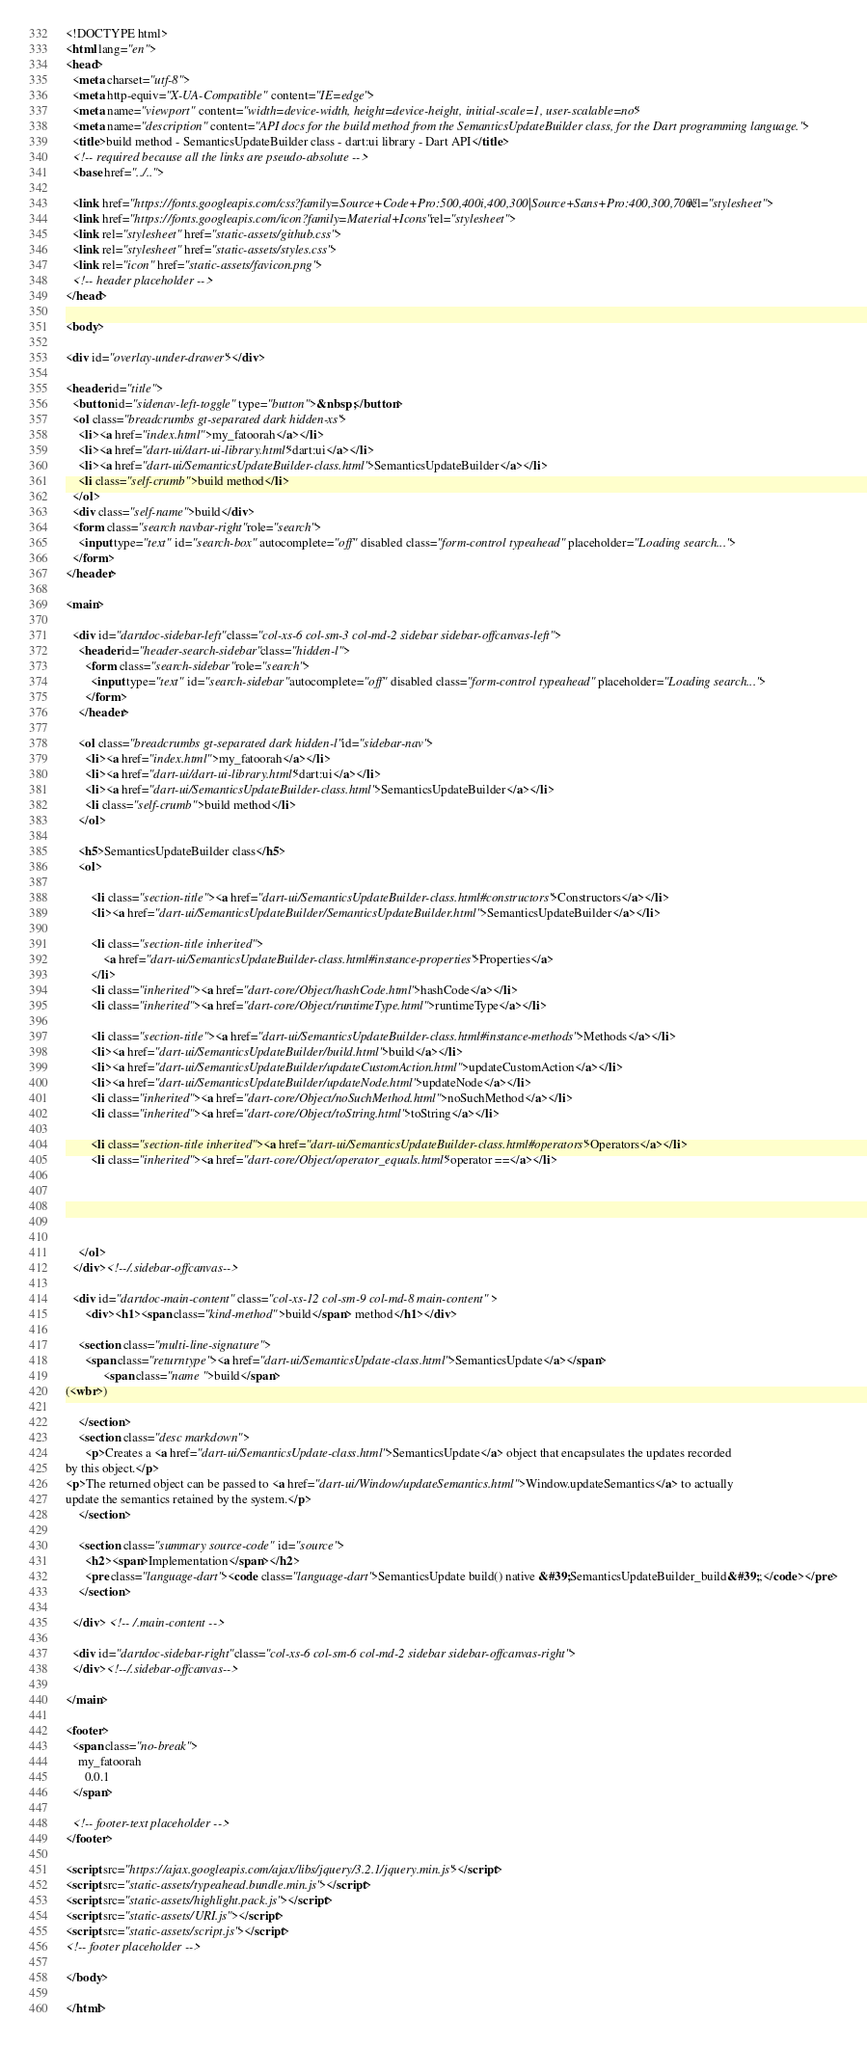<code> <loc_0><loc_0><loc_500><loc_500><_HTML_><!DOCTYPE html>
<html lang="en">
<head>
  <meta charset="utf-8">
  <meta http-equiv="X-UA-Compatible" content="IE=edge">
  <meta name="viewport" content="width=device-width, height=device-height, initial-scale=1, user-scalable=no">
  <meta name="description" content="API docs for the build method from the SemanticsUpdateBuilder class, for the Dart programming language.">
  <title>build method - SemanticsUpdateBuilder class - dart:ui library - Dart API</title>
  <!-- required because all the links are pseudo-absolute -->
  <base href="../..">

  <link href="https://fonts.googleapis.com/css?family=Source+Code+Pro:500,400i,400,300|Source+Sans+Pro:400,300,700" rel="stylesheet">
  <link href="https://fonts.googleapis.com/icon?family=Material+Icons" rel="stylesheet">
  <link rel="stylesheet" href="static-assets/github.css">
  <link rel="stylesheet" href="static-assets/styles.css">
  <link rel="icon" href="static-assets/favicon.png">
  <!-- header placeholder -->
</head>

<body>

<div id="overlay-under-drawer"></div>

<header id="title">
  <button id="sidenav-left-toggle" type="button">&nbsp;</button>
  <ol class="breadcrumbs gt-separated dark hidden-xs">
    <li><a href="index.html">my_fatoorah</a></li>
    <li><a href="dart-ui/dart-ui-library.html">dart:ui</a></li>
    <li><a href="dart-ui/SemanticsUpdateBuilder-class.html">SemanticsUpdateBuilder</a></li>
    <li class="self-crumb">build method</li>
  </ol>
  <div class="self-name">build</div>
  <form class="search navbar-right" role="search">
    <input type="text" id="search-box" autocomplete="off" disabled class="form-control typeahead" placeholder="Loading search...">
  </form>
</header>

<main>

  <div id="dartdoc-sidebar-left" class="col-xs-6 col-sm-3 col-md-2 sidebar sidebar-offcanvas-left">
    <header id="header-search-sidebar" class="hidden-l">
      <form class="search-sidebar" role="search">
        <input type="text" id="search-sidebar" autocomplete="off" disabled class="form-control typeahead" placeholder="Loading search...">
      </form>
    </header>
    
    <ol class="breadcrumbs gt-separated dark hidden-l" id="sidebar-nav">
      <li><a href="index.html">my_fatoorah</a></li>
      <li><a href="dart-ui/dart-ui-library.html">dart:ui</a></li>
      <li><a href="dart-ui/SemanticsUpdateBuilder-class.html">SemanticsUpdateBuilder</a></li>
      <li class="self-crumb">build method</li>
    </ol>
    
    <h5>SemanticsUpdateBuilder class</h5>
    <ol>
    
        <li class="section-title"><a href="dart-ui/SemanticsUpdateBuilder-class.html#constructors">Constructors</a></li>
        <li><a href="dart-ui/SemanticsUpdateBuilder/SemanticsUpdateBuilder.html">SemanticsUpdateBuilder</a></li>
    
        <li class="section-title inherited">
            <a href="dart-ui/SemanticsUpdateBuilder-class.html#instance-properties">Properties</a>
        </li>
        <li class="inherited"><a href="dart-core/Object/hashCode.html">hashCode</a></li>
        <li class="inherited"><a href="dart-core/Object/runtimeType.html">runtimeType</a></li>
    
        <li class="section-title"><a href="dart-ui/SemanticsUpdateBuilder-class.html#instance-methods">Methods</a></li>
        <li><a href="dart-ui/SemanticsUpdateBuilder/build.html">build</a></li>
        <li><a href="dart-ui/SemanticsUpdateBuilder/updateCustomAction.html">updateCustomAction</a></li>
        <li><a href="dart-ui/SemanticsUpdateBuilder/updateNode.html">updateNode</a></li>
        <li class="inherited"><a href="dart-core/Object/noSuchMethod.html">noSuchMethod</a></li>
        <li class="inherited"><a href="dart-core/Object/toString.html">toString</a></li>
    
        <li class="section-title inherited"><a href="dart-ui/SemanticsUpdateBuilder-class.html#operators">Operators</a></li>
        <li class="inherited"><a href="dart-core/Object/operator_equals.html">operator ==</a></li>
    
    
    
    
    
    </ol>
  </div><!--/.sidebar-offcanvas-->

  <div id="dartdoc-main-content" class="col-xs-12 col-sm-9 col-md-8 main-content">
      <div><h1><span class="kind-method">build</span> method</h1></div>

    <section class="multi-line-signature">
      <span class="returntype"><a href="dart-ui/SemanticsUpdate-class.html">SemanticsUpdate</a></span>
            <span class="name ">build</span>
(<wbr>)
      
    </section>
    <section class="desc markdown">
      <p>Creates a <a href="dart-ui/SemanticsUpdate-class.html">SemanticsUpdate</a> object that encapsulates the updates recorded
by this object.</p>
<p>The returned object can be passed to <a href="dart-ui/Window/updateSemantics.html">Window.updateSemantics</a> to actually
update the semantics retained by the system.</p>
    </section>
    
    <section class="summary source-code" id="source">
      <h2><span>Implementation</span></h2>
      <pre class="language-dart"><code class="language-dart">SemanticsUpdate build() native &#39;SemanticsUpdateBuilder_build&#39;;</code></pre>
    </section>

  </div> <!-- /.main-content -->

  <div id="dartdoc-sidebar-right" class="col-xs-6 col-sm-6 col-md-2 sidebar sidebar-offcanvas-right">
  </div><!--/.sidebar-offcanvas-->

</main>

<footer>
  <span class="no-break">
    my_fatoorah
      0.0.1
  </span>

  <!-- footer-text placeholder -->
</footer>

<script src="https://ajax.googleapis.com/ajax/libs/jquery/3.2.1/jquery.min.js"></script>
<script src="static-assets/typeahead.bundle.min.js"></script>
<script src="static-assets/highlight.pack.js"></script>
<script src="static-assets/URI.js"></script>
<script src="static-assets/script.js"></script>
<!-- footer placeholder -->

</body>

</html>
</code> 